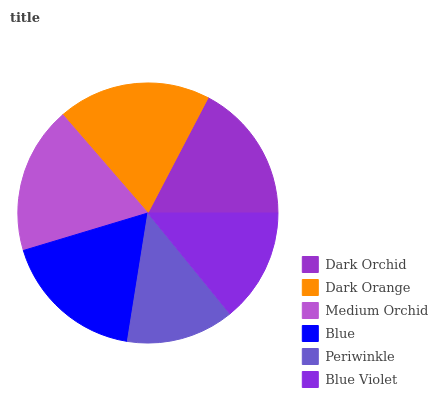Is Periwinkle the minimum?
Answer yes or no. Yes. Is Dark Orange the maximum?
Answer yes or no. Yes. Is Medium Orchid the minimum?
Answer yes or no. No. Is Medium Orchid the maximum?
Answer yes or no. No. Is Dark Orange greater than Medium Orchid?
Answer yes or no. Yes. Is Medium Orchid less than Dark Orange?
Answer yes or no. Yes. Is Medium Orchid greater than Dark Orange?
Answer yes or no. No. Is Dark Orange less than Medium Orchid?
Answer yes or no. No. Is Blue the high median?
Answer yes or no. Yes. Is Dark Orchid the low median?
Answer yes or no. Yes. Is Blue Violet the high median?
Answer yes or no. No. Is Blue the low median?
Answer yes or no. No. 